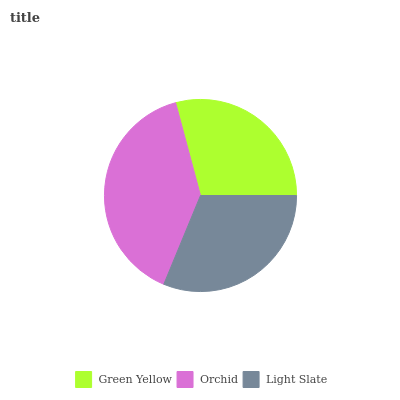Is Green Yellow the minimum?
Answer yes or no. Yes. Is Orchid the maximum?
Answer yes or no. Yes. Is Light Slate the minimum?
Answer yes or no. No. Is Light Slate the maximum?
Answer yes or no. No. Is Orchid greater than Light Slate?
Answer yes or no. Yes. Is Light Slate less than Orchid?
Answer yes or no. Yes. Is Light Slate greater than Orchid?
Answer yes or no. No. Is Orchid less than Light Slate?
Answer yes or no. No. Is Light Slate the high median?
Answer yes or no. Yes. Is Light Slate the low median?
Answer yes or no. Yes. Is Orchid the high median?
Answer yes or no. No. Is Green Yellow the low median?
Answer yes or no. No. 